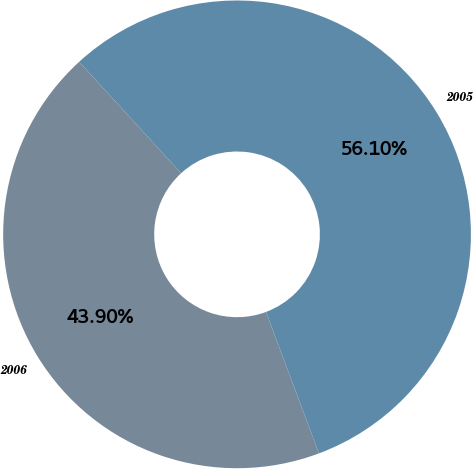Convert chart to OTSL. <chart><loc_0><loc_0><loc_500><loc_500><pie_chart><fcel>2006<fcel>2005<nl><fcel>43.9%<fcel>56.1%<nl></chart> 